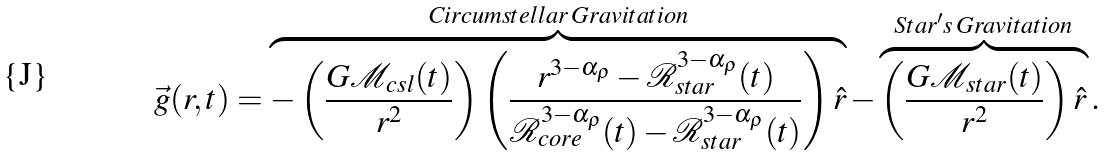Convert formula to latex. <formula><loc_0><loc_0><loc_500><loc_500>\vec { g } ( r , t ) = \overbrace { - \left ( \frac { G \mathcal { M } _ { c s l } ( t ) } { r ^ { 2 } } \right ) \left ( \frac { r ^ { 3 - \alpha _ { \rho } } - \mathcal { R } _ { s t a r } ^ { 3 - \alpha _ { \rho } } ( t ) } { \mathcal { R } ^ { 3 - \alpha _ { \rho } } _ { c o r e } ( t ) - \mathcal { R } _ { s t a r } ^ { 3 - \alpha _ { \rho } } ( t ) } \right ) \hat { r } } ^ { C i r c u m s t e l l a r \, G r a v i t a t i o n } - \overbrace { \left ( \frac { G \mathcal { M } _ { s t a r } ( t ) } { r ^ { 2 } } \right ) \hat { r } } ^ { S t a r ^ { \prime } s \, G r a v i t a t i o n } .</formula> 